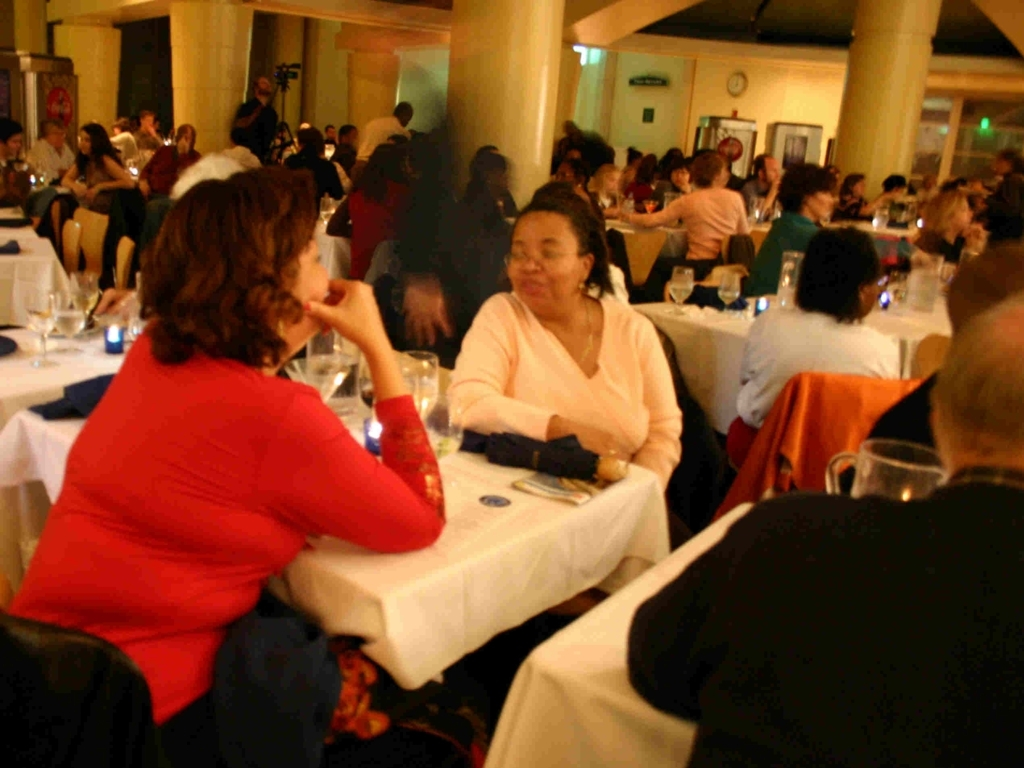What is the level of blurriness of the features of the crowd in the background?
A. Sharp
B. Clear
C. Blurred
Answer with the option's letter from the given choices directly. The correct answer to the question is C, Blurred. The crowd in the background exhibits a lack of sharpness in their features, resulting in a blurred effect. This blurriness could be due to a combination of motion, the depth of field set by the photographer, and the lighting conditions in which the photo was taken. 